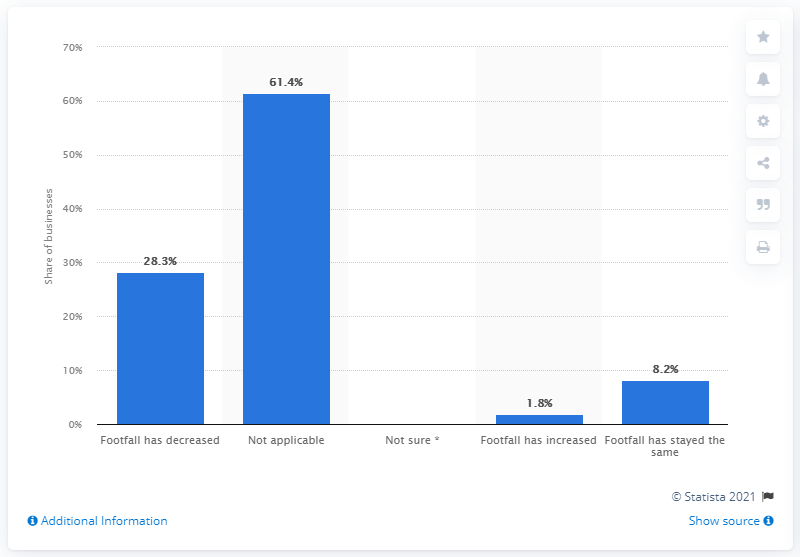Specify some key components in this picture. In the last week, 1.8% of businesses in the arts, entertainment, and recreation industry reported an increase in foot traffic. 